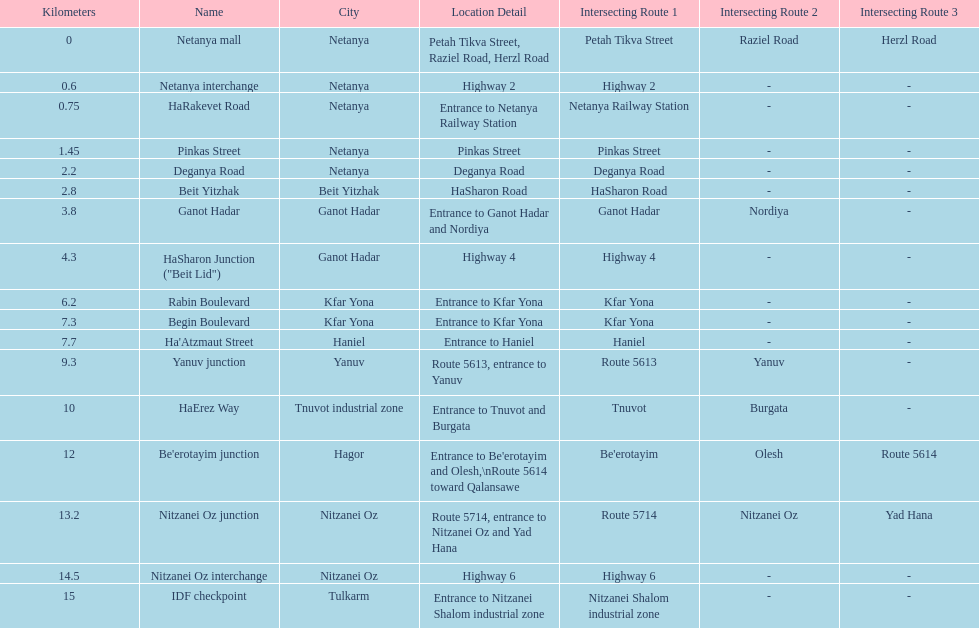Which section is longest?? IDF checkpoint. 